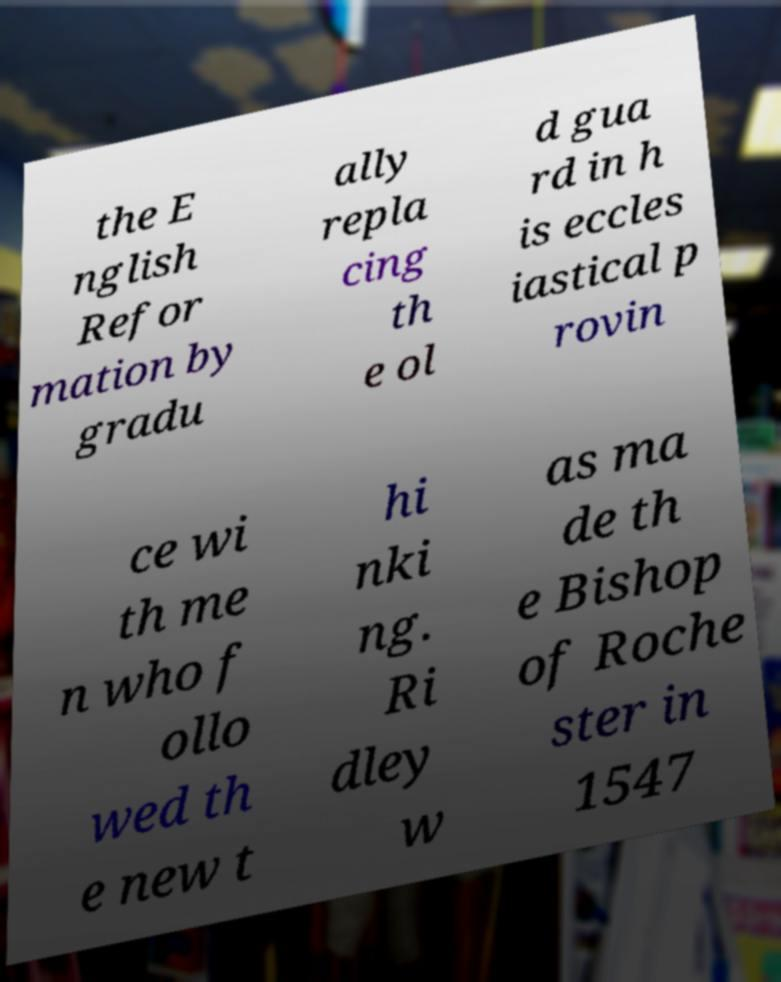Can you read and provide the text displayed in the image?This photo seems to have some interesting text. Can you extract and type it out for me? the E nglish Refor mation by gradu ally repla cing th e ol d gua rd in h is eccles iastical p rovin ce wi th me n who f ollo wed th e new t hi nki ng. Ri dley w as ma de th e Bishop of Roche ster in 1547 